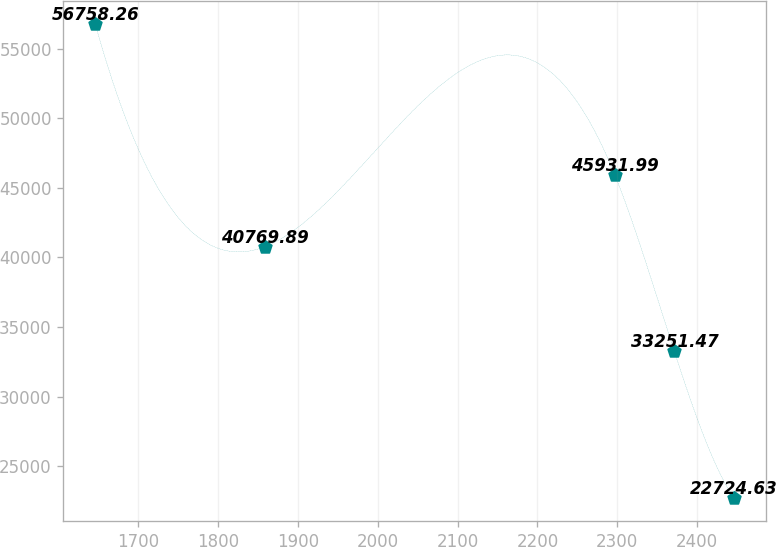<chart> <loc_0><loc_0><loc_500><loc_500><line_chart><ecel><fcel>Unnamed: 1<nl><fcel>1646.37<fcel>56758.3<nl><fcel>1858.52<fcel>40769.9<nl><fcel>2297<fcel>45932<nl><fcel>2371.5<fcel>33251.5<nl><fcel>2446<fcel>22724.6<nl></chart> 